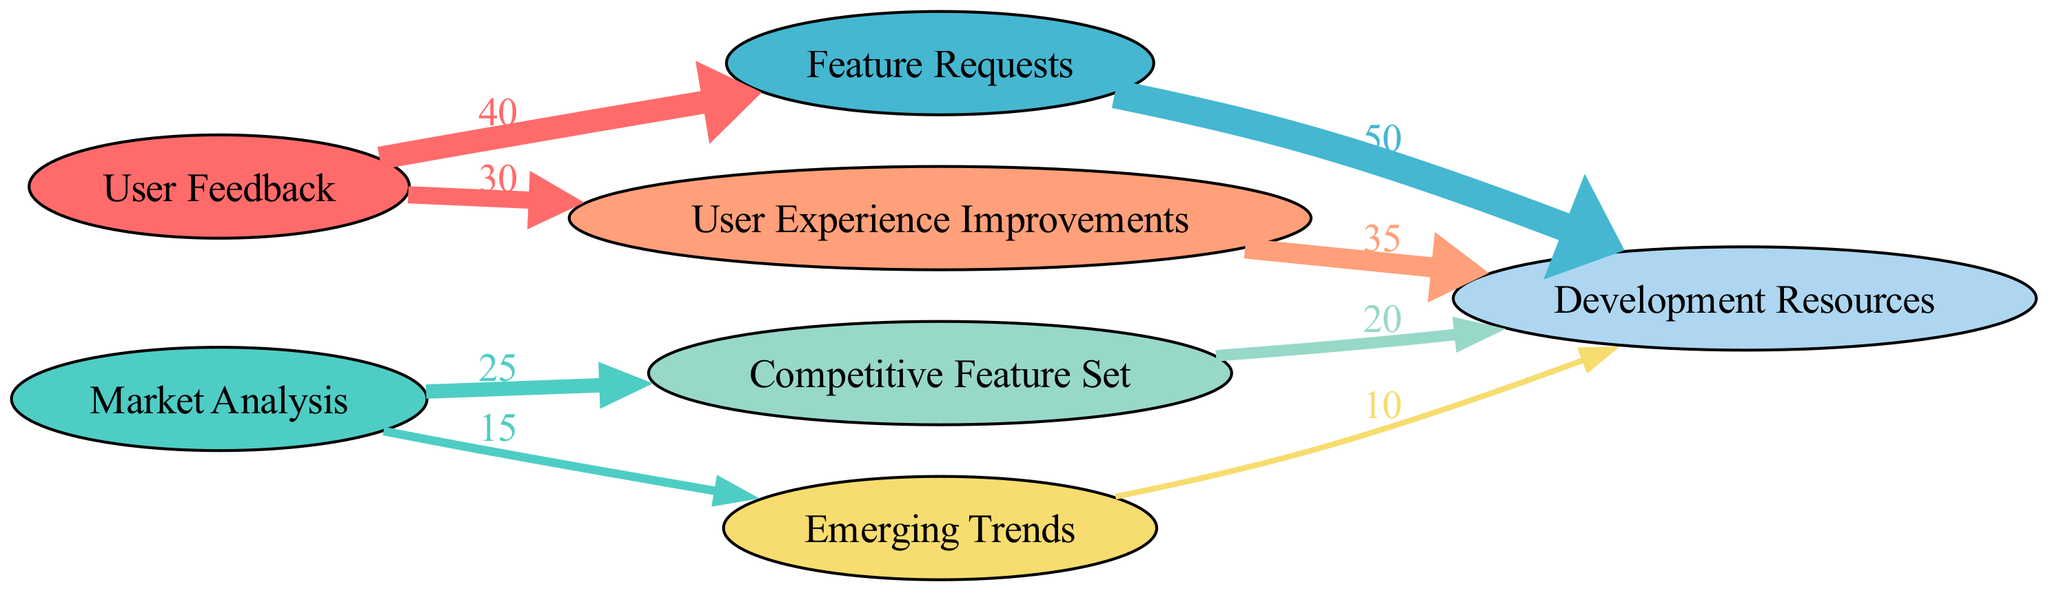What is the total value of User Feedback? The diagram shows a connection from User Feedback to Feature Requests with a value of 40, and to User Experience Improvements with a value of 30. To find the total value, we add these two values together: 40 + 30 = 70.
Answer: 70 What is the value associated with Competitive Feature Set? The diagram illustrates that Competitive Feature Set receives a value of 20 as it connects to Development Resources.
Answer: 20 How many edges are there leading from Market Analysis? The diagram reveals that there are two edges stemming from Market Analysis: one to Competitive Feature Set with a value of 25 and one to Emerging Trends with a value of 15. Therefore, there are 2 edges.
Answer: 2 Which feature has the highest value of Development Resources? By examining the outgoing edges from the feature nodes to Development Resources, the highest value is from Feature Requests, with a value of 50, which is greater than other values.
Answer: Feature Requests What is the total value of Development Resources incurred by User Experience Improvements and Competitive Feature Set? There are two edges leading to Development Resources from these nodes: User Experience Improvements with a value of 35 and Competitive Feature Set with a value of 20. We add these two values: 35 + 20 = 55.
Answer: 55 Which source contributes the least to Development Resources? Emerging Trends has the lowest outgoing value to Development Resources at 10, as compared to the other sources like Feature Requests and User Experience Improvements.
Answer: Emerging Trends What proportion of Feature Requests uses Development Resources? Feature Requests has a value of 50 going to Development Resources, while the total inputs into Development Resources can be computed by adding up 50, 35, 20, and 10, which gives us 115. To find the proportion, we calculate: 50 / 115 = 0.4348. This results in the proportion being approximately 43%.
Answer: 43% How many unique feature categories are derived from User Feedback? The diagram shows User Feedback resulting in two unique categories: Feature Requests and User Experience Improvements. Thus, there are 2 unique categories.
Answer: 2 What is the sum of values flowing from Market Analysis? The values flowing from Market Analysis include Competitive Feature Set with 25 and Emerging Trends with 15. Adding these values gives us: 25 + 15 = 40.
Answer: 40 